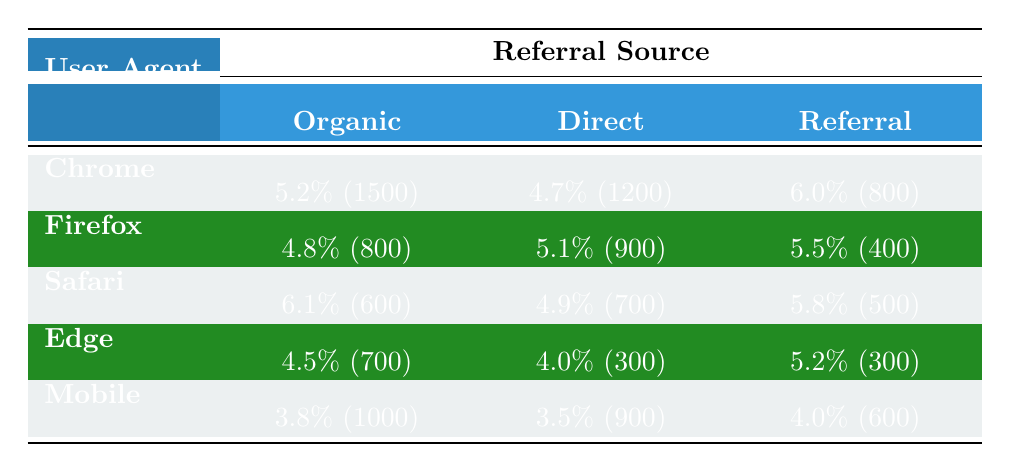What is the conversion rate for Chrome users from the Referral source? Referring to the table, the conversion rate for Chrome users from the Referral source is 6.0%.
Answer: 6.0% What is the total number of sessions recorded for Firefox users? By adding the sessions from all referral sources for Firefox: 800 (Organic) + 900 (Direct) + 400 (Referral) = 2100 sessions.
Answer: 2100 Which user agent has the highest conversion rate from the Organic source? Looking at the Organic conversion rates, Safari has the highest rate at 6.1%.
Answer: Safari Is the average conversion rate for Mobile users higher than that for Edge users? The average for Mobile is (3.8 + 3.5 + 4.0) / 3 = 3.77, and for Edge it is (4.5 + 4.0 + 5.2) / 3 = 4.23. Since 3.77 is less than 4.23, it is not higher.
Answer: No What is the difference between the conversion rates of Direct and Referral sources for Chrome? The conversion rate for Chrome from Direct is 4.7% and from Referral is 6.0%. The difference is 6.0% - 4.7% = 1.3%.
Answer: 1.3% Which user agent has the lowest overall conversion rate across all sources? The overall conversion rates are: Chrome (5.2 + 4.7 + 6.0)/3 = 5.33%, Firefox (4.8 + 5.1 + 5.5)/3 = 5.13%, Safari (6.1 + 4.9 + 5.8)/3 = 5.63%, Edge (4.5 + 4.0 + 5.2)/3 = 4.57%, Mobile (3.8 + 3.5 + 4.0)/3 = 3.77%. Mobile has the lowest overall conversion rate of 3.77%.
Answer: Mobile If we compare the Referral conversion rates, what is the rank of user agents from highest to lowest? The Referral rates are: Chrome (6.0%), Firefox (5.5%), Safari (5.8%), Edge (5.2%), Mobile (4.0%). Ranking them gives: 1. Chrome, 2. Safari, 3. Firefox, 4. Edge, 5. Mobile.
Answer: Chrome, Safari, Firefox, Edge, Mobile What is the conversion rate change from Organic to Referral for Safari users? The Organic conversion rate for Safari is 6.1% and the Referral conversion rate is 5.8%. The change is 5.8% - 6.1% = -0.3%.
Answer: -0.3% 